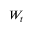<formula> <loc_0><loc_0><loc_500><loc_500>W _ { t }</formula> 